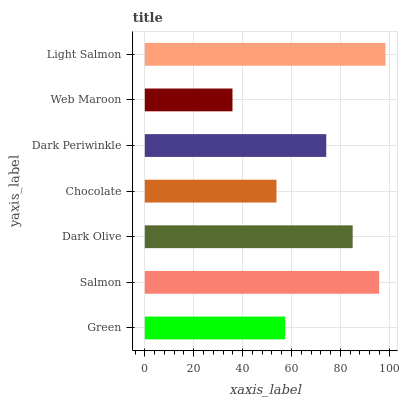Is Web Maroon the minimum?
Answer yes or no. Yes. Is Light Salmon the maximum?
Answer yes or no. Yes. Is Salmon the minimum?
Answer yes or no. No. Is Salmon the maximum?
Answer yes or no. No. Is Salmon greater than Green?
Answer yes or no. Yes. Is Green less than Salmon?
Answer yes or no. Yes. Is Green greater than Salmon?
Answer yes or no. No. Is Salmon less than Green?
Answer yes or no. No. Is Dark Periwinkle the high median?
Answer yes or no. Yes. Is Dark Periwinkle the low median?
Answer yes or no. Yes. Is Salmon the high median?
Answer yes or no. No. Is Light Salmon the low median?
Answer yes or no. No. 